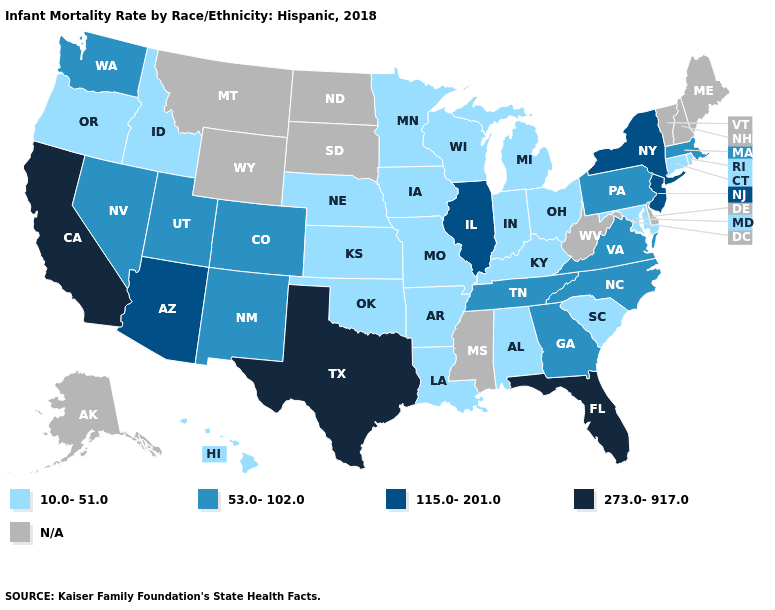Name the states that have a value in the range 10.0-51.0?
Quick response, please. Alabama, Arkansas, Connecticut, Hawaii, Idaho, Indiana, Iowa, Kansas, Kentucky, Louisiana, Maryland, Michigan, Minnesota, Missouri, Nebraska, Ohio, Oklahoma, Oregon, Rhode Island, South Carolina, Wisconsin. Does Kansas have the lowest value in the MidWest?
Quick response, please. Yes. Name the states that have a value in the range 53.0-102.0?
Give a very brief answer. Colorado, Georgia, Massachusetts, Nevada, New Mexico, North Carolina, Pennsylvania, Tennessee, Utah, Virginia, Washington. Name the states that have a value in the range 53.0-102.0?
Be succinct. Colorado, Georgia, Massachusetts, Nevada, New Mexico, North Carolina, Pennsylvania, Tennessee, Utah, Virginia, Washington. Does Texas have the highest value in the USA?
Short answer required. Yes. Which states hav the highest value in the MidWest?
Answer briefly. Illinois. What is the value of North Dakota?
Keep it brief. N/A. Name the states that have a value in the range 10.0-51.0?
Be succinct. Alabama, Arkansas, Connecticut, Hawaii, Idaho, Indiana, Iowa, Kansas, Kentucky, Louisiana, Maryland, Michigan, Minnesota, Missouri, Nebraska, Ohio, Oklahoma, Oregon, Rhode Island, South Carolina, Wisconsin. Name the states that have a value in the range 115.0-201.0?
Keep it brief. Arizona, Illinois, New Jersey, New York. What is the highest value in the South ?
Answer briefly. 273.0-917.0. Name the states that have a value in the range 53.0-102.0?
Give a very brief answer. Colorado, Georgia, Massachusetts, Nevada, New Mexico, North Carolina, Pennsylvania, Tennessee, Utah, Virginia, Washington. What is the highest value in the USA?
Short answer required. 273.0-917.0. What is the highest value in the MidWest ?
Give a very brief answer. 115.0-201.0. How many symbols are there in the legend?
Concise answer only. 5. Is the legend a continuous bar?
Give a very brief answer. No. 